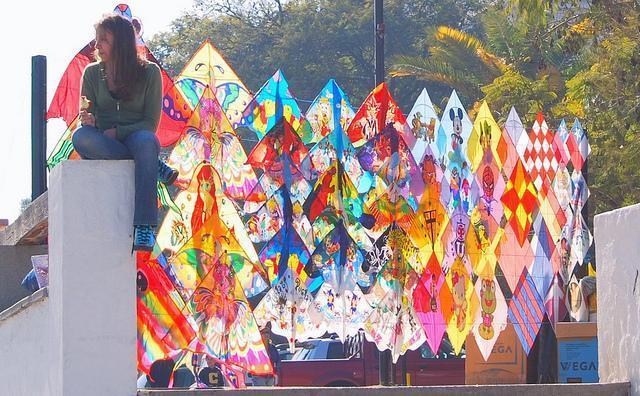How many kites can be seen?
Give a very brief answer. 8. 